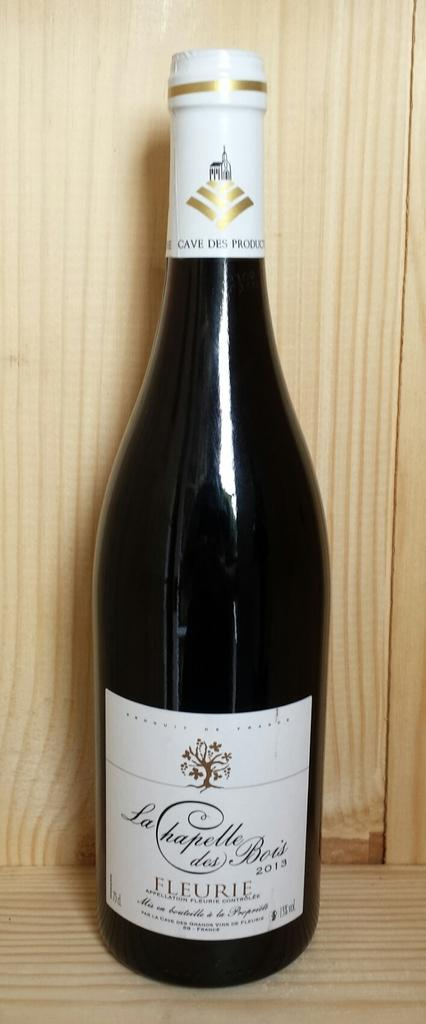<image>
Render a clear and concise summary of the photo. A WINE BOTTLE WITH A WHITE LABEL THAT SAYS "LA CHAPELLE DES BOIS 2013 FLEURIE" 